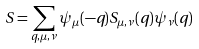<formula> <loc_0><loc_0><loc_500><loc_500>S = \sum _ { q , \mu , \nu } \psi _ { \mu } ( - q ) S _ { \mu , \nu } ( q ) \psi _ { \nu } ( q )</formula> 